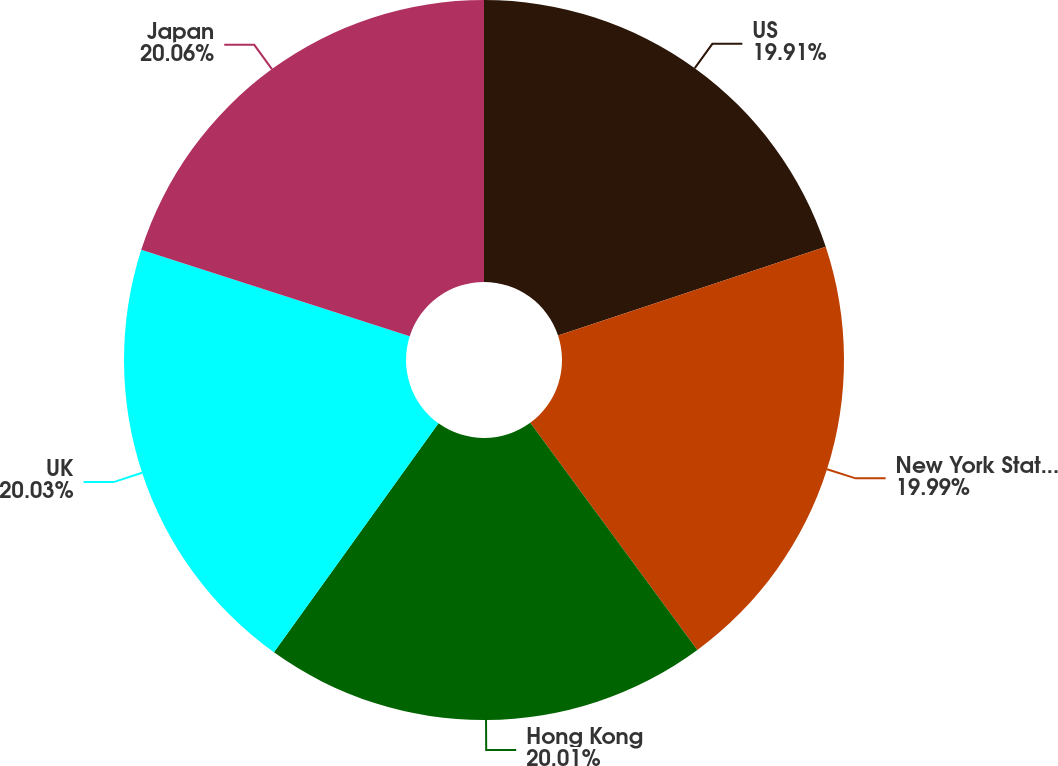Convert chart. <chart><loc_0><loc_0><loc_500><loc_500><pie_chart><fcel>US<fcel>New York State and New York<fcel>Hong Kong<fcel>UK<fcel>Japan<nl><fcel>19.91%<fcel>19.99%<fcel>20.01%<fcel>20.03%<fcel>20.05%<nl></chart> 